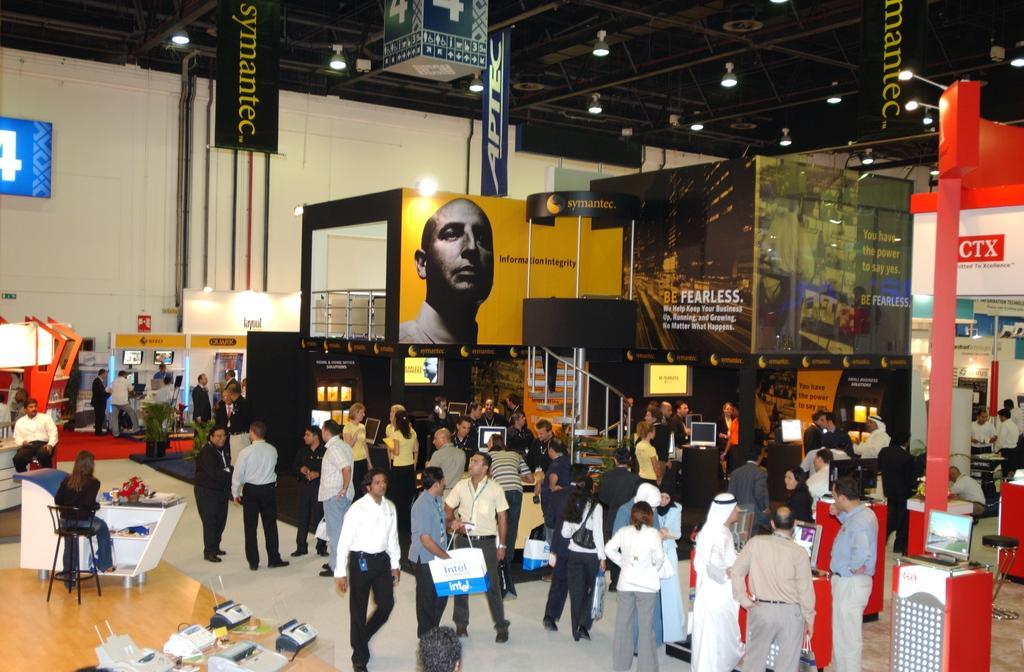Can you describe this image briefly? This picture is clicked inside the hall and we can see the group of people standing on the ground. On the left we can see a person walking on the ground and we can see the two people sitting on the chairs and we can see the electronic devices and the tables and many other objects. In the background we can see the wall, and the text and the depiction of a person on the banners and we can see the staircase, handrail and some other items. At the top there is a roof and the lights. 